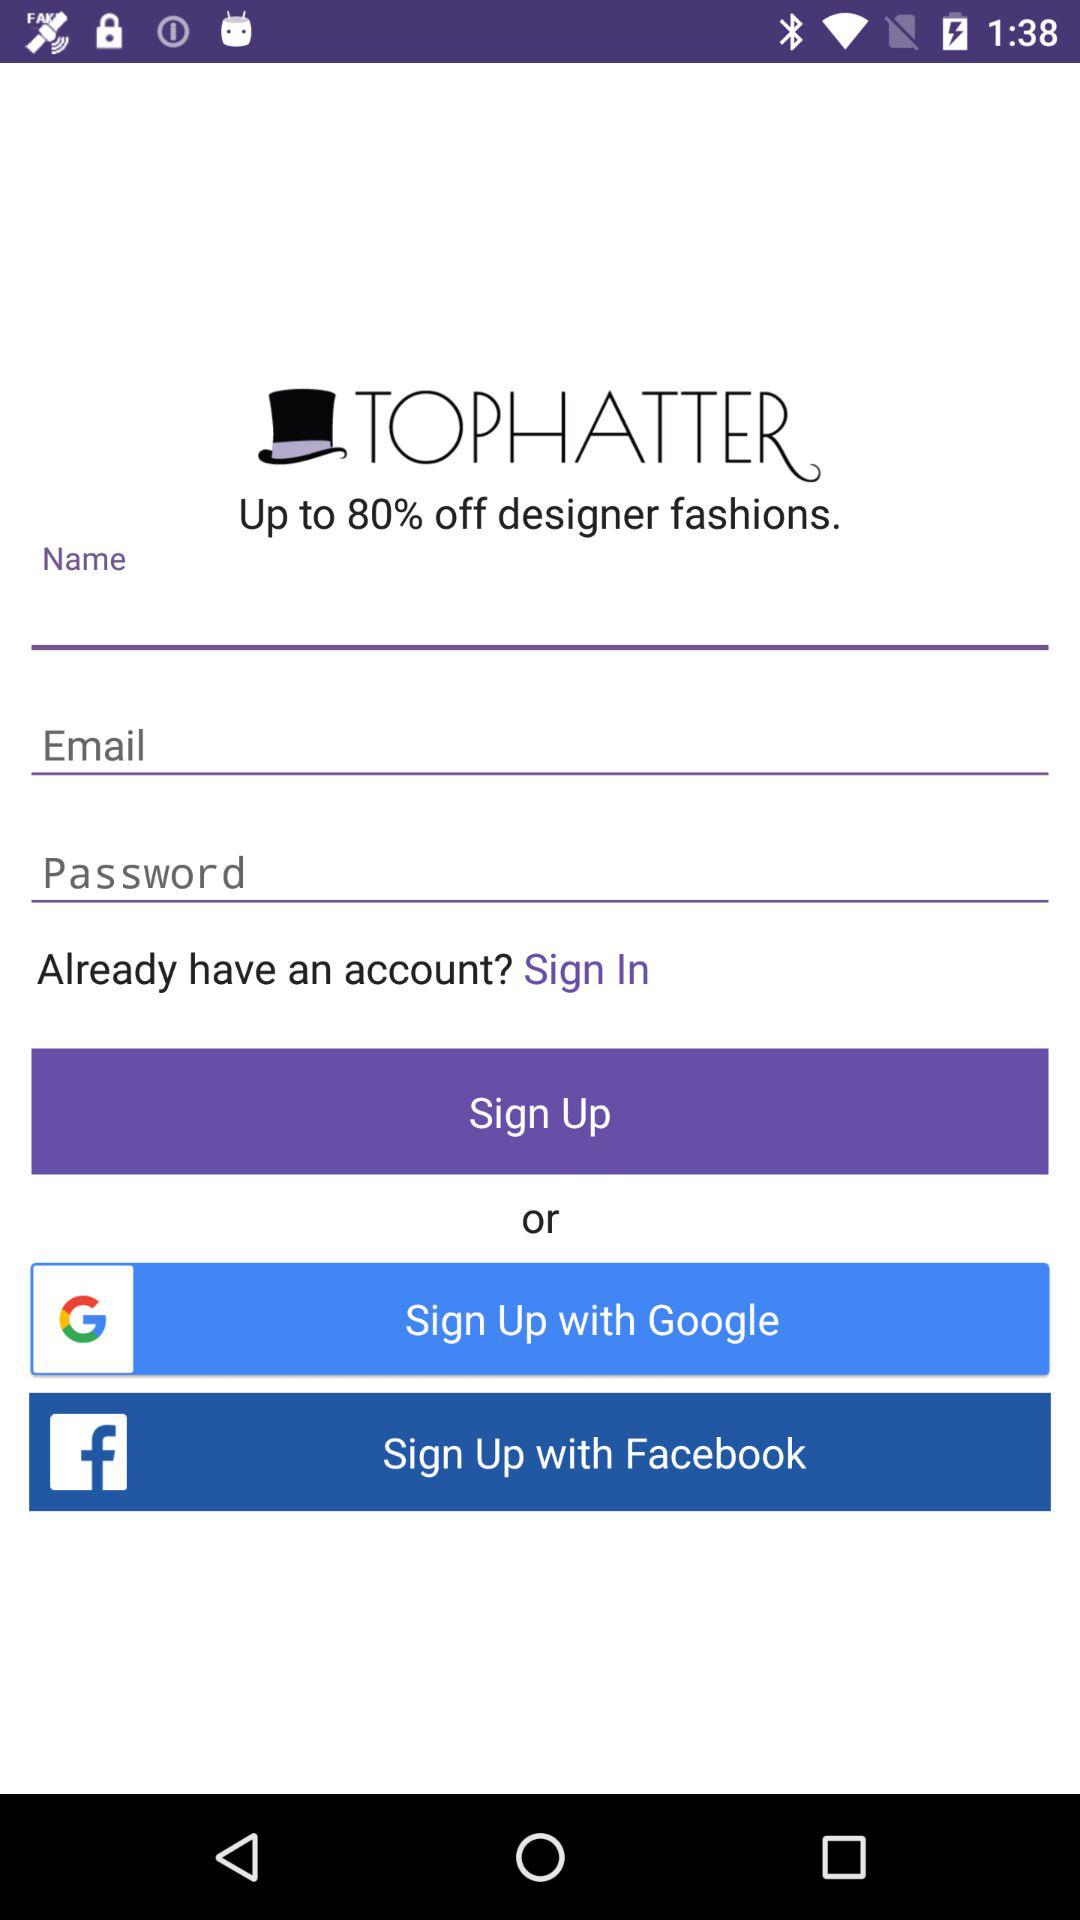What is the percentage off on designer fashions? The percentage off on designer fashions is up to 80. 